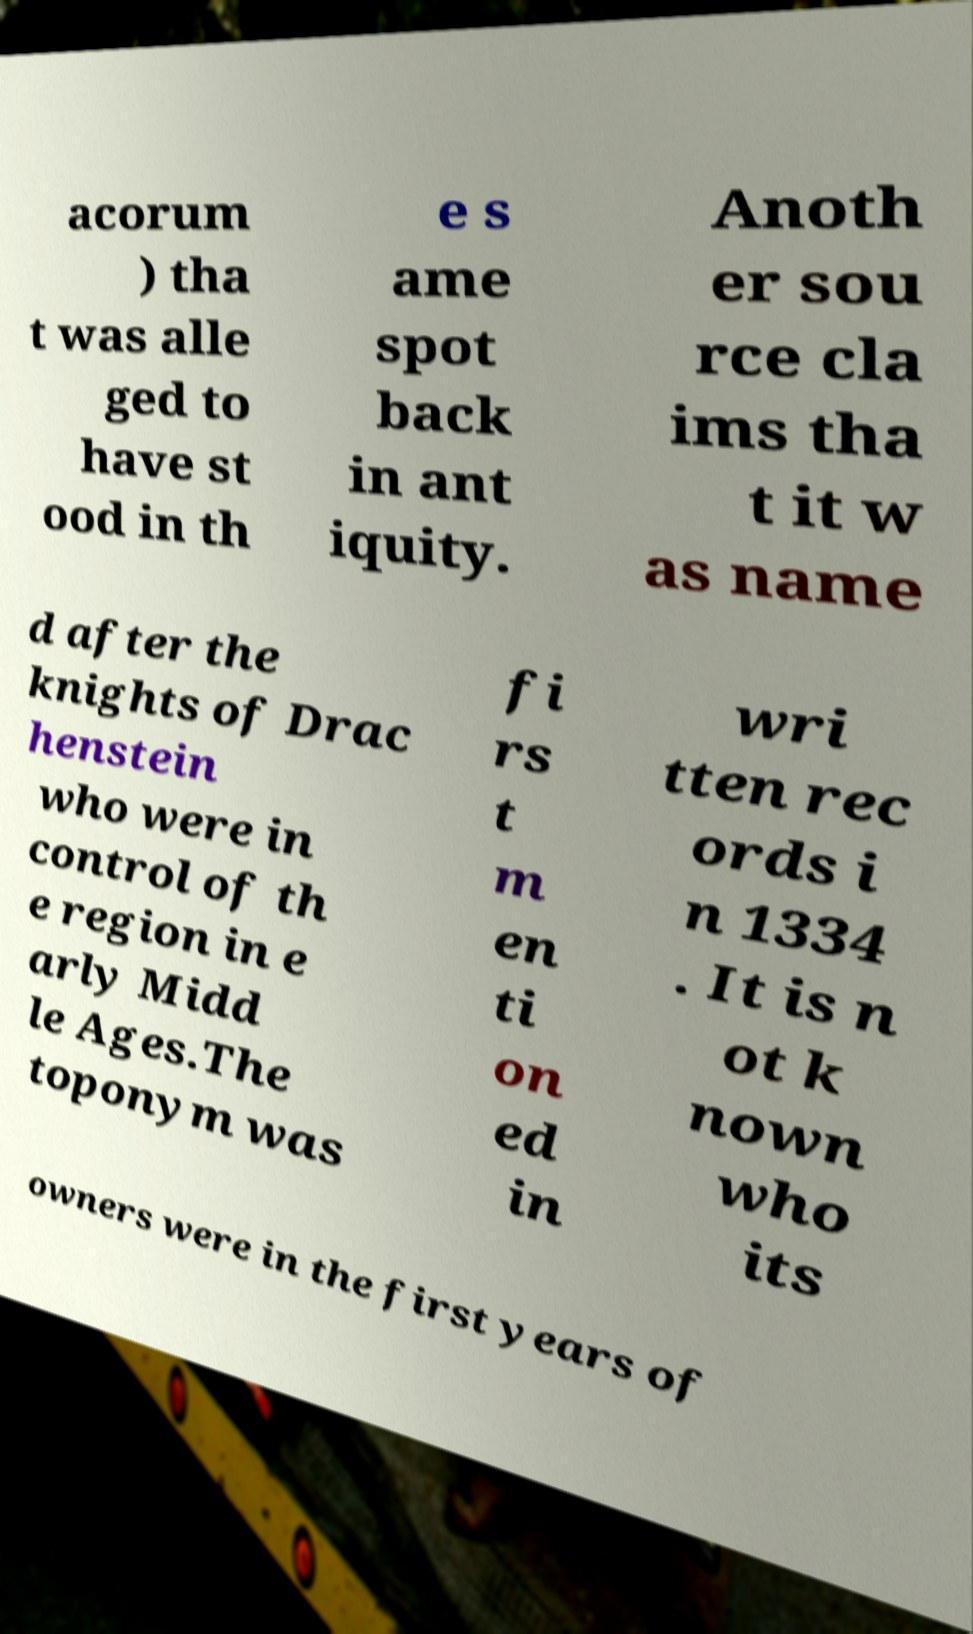For documentation purposes, I need the text within this image transcribed. Could you provide that? acorum ) tha t was alle ged to have st ood in th e s ame spot back in ant iquity. Anoth er sou rce cla ims tha t it w as name d after the knights of Drac henstein who were in control of th e region in e arly Midd le Ages.The toponym was fi rs t m en ti on ed in wri tten rec ords i n 1334 . It is n ot k nown who its owners were in the first years of 